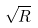Convert formula to latex. <formula><loc_0><loc_0><loc_500><loc_500>\sqrt { R }</formula> 